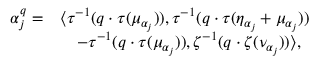<formula> <loc_0><loc_0><loc_500><loc_500>\begin{array} { r l } { \alpha _ { j } ^ { q } = } & { \left \langle \tau ^ { - 1 } ( q \cdot \tau ( \mu _ { \alpha _ { j } } ) ) , \tau ^ { - 1 } ( q \cdot \tau ( \eta _ { \alpha _ { j } } + \mu _ { \alpha _ { j } } ) ) } \\ & { \quad - \tau ^ { - 1 } ( q \cdot \tau ( \mu _ { \alpha _ { j } } ) ) , \zeta ^ { - 1 } ( q \cdot \zeta ( \nu _ { \alpha _ { j } } ) ) \right \rangle , } \end{array}</formula> 